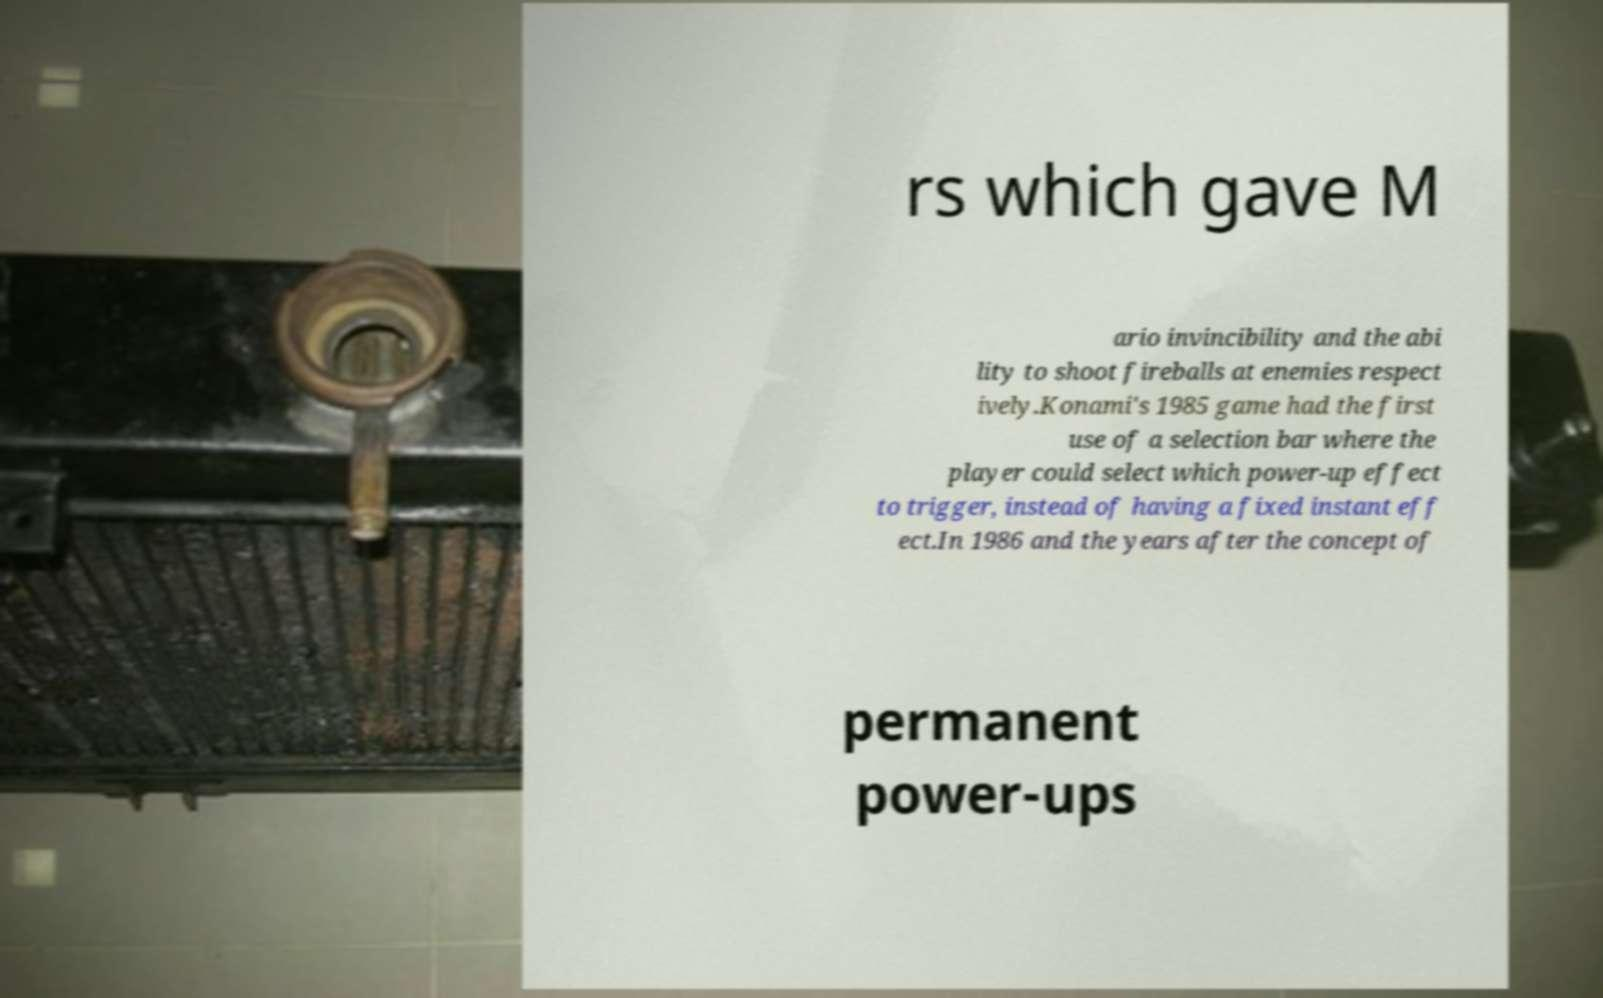I need the written content from this picture converted into text. Can you do that? rs which gave M ario invincibility and the abi lity to shoot fireballs at enemies respect ively.Konami's 1985 game had the first use of a selection bar where the player could select which power-up effect to trigger, instead of having a fixed instant eff ect.In 1986 and the years after the concept of permanent power-ups 